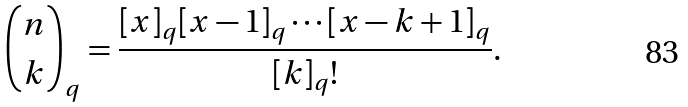Convert formula to latex. <formula><loc_0><loc_0><loc_500><loc_500>\binom { n } { k } _ { q } = \frac { [ x ] _ { q } [ x - 1 ] _ { q } \cdots [ x - k + 1 ] _ { q } } { [ k ] _ { q } ! } .</formula> 